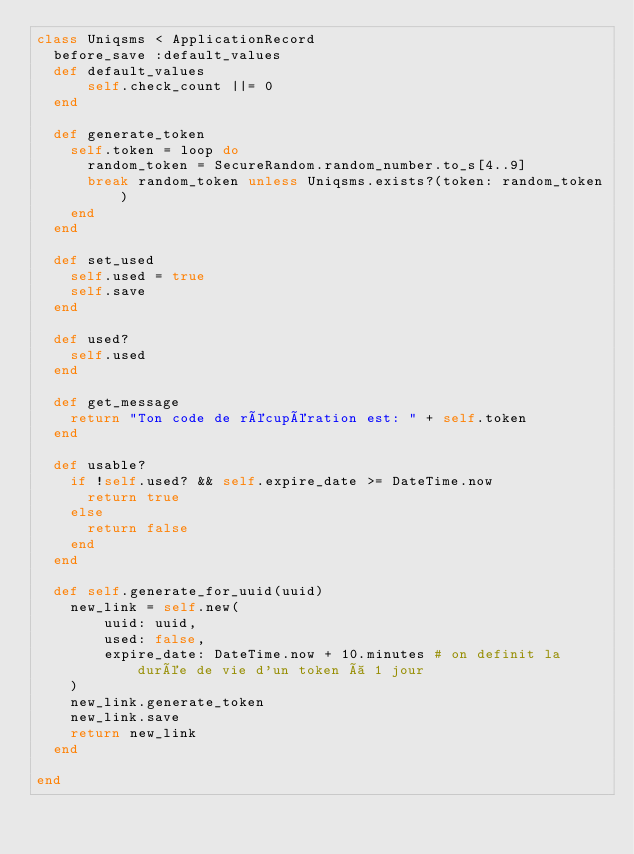<code> <loc_0><loc_0><loc_500><loc_500><_Ruby_>class Uniqsms < ApplicationRecord
	before_save :default_values
	def default_values
	    self.check_count ||= 0
	end

	def generate_token
		self.token = loop do
			random_token = SecureRandom.random_number.to_s[4..9]
			break random_token unless Uniqsms.exists?(token: random_token)
		end
	end

	def set_used
		self.used = true
		self.save
	end

	def used?
		self.used
	end

	def get_message
		return "Ton code de récupération est: " + self.token
	end

	def usable?
		if !self.used? && self.expire_date >= DateTime.now
			return true
		else
			return false
		end
	end

	def self.generate_for_uuid(uuid)
		new_link = self.new(
				uuid: uuid,
				used: false,
				expire_date: DateTime.now + 10.minutes # on definit la durée de vie d'un token à 1 jour
		)
		new_link.generate_token
		new_link.save
		return new_link
	end

end
</code> 